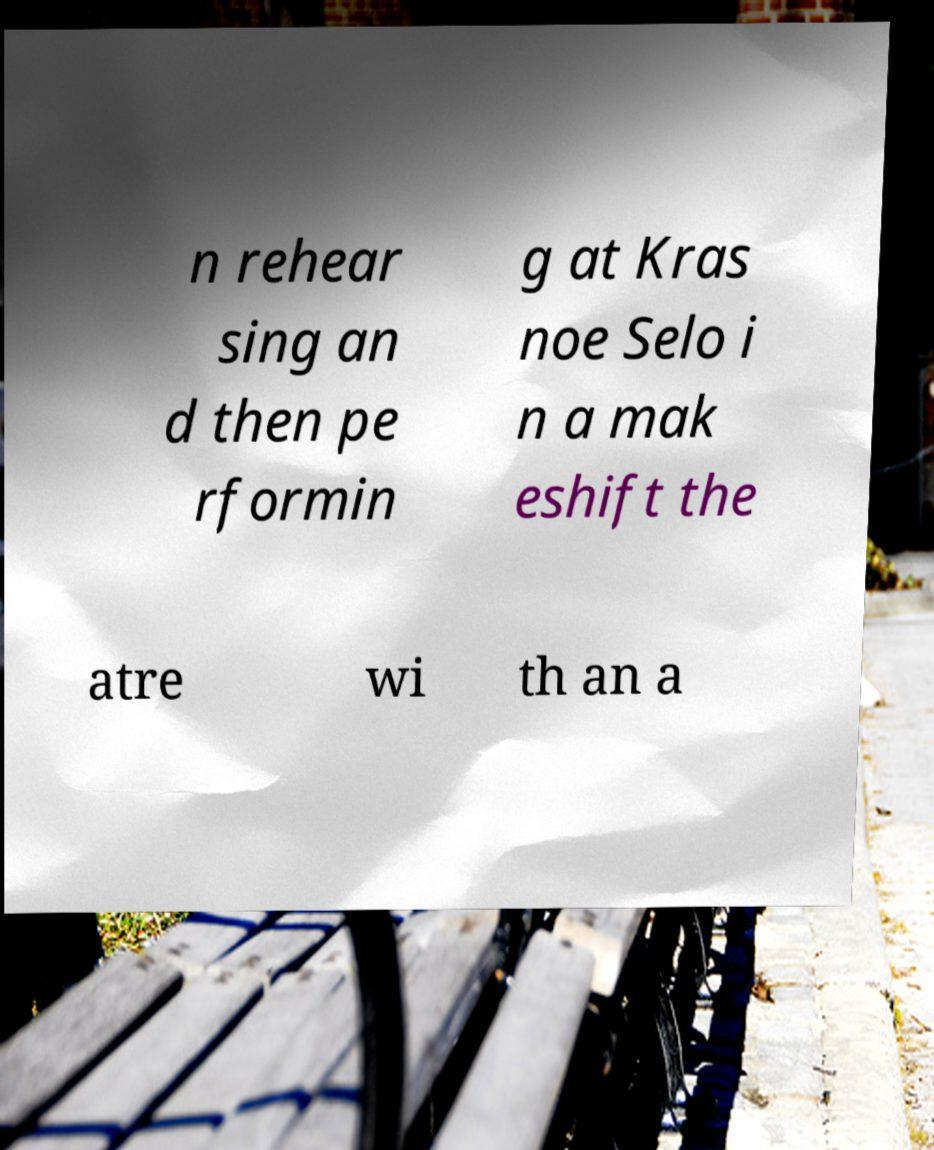I need the written content from this picture converted into text. Can you do that? n rehear sing an d then pe rformin g at Kras noe Selo i n a mak eshift the atre wi th an a 